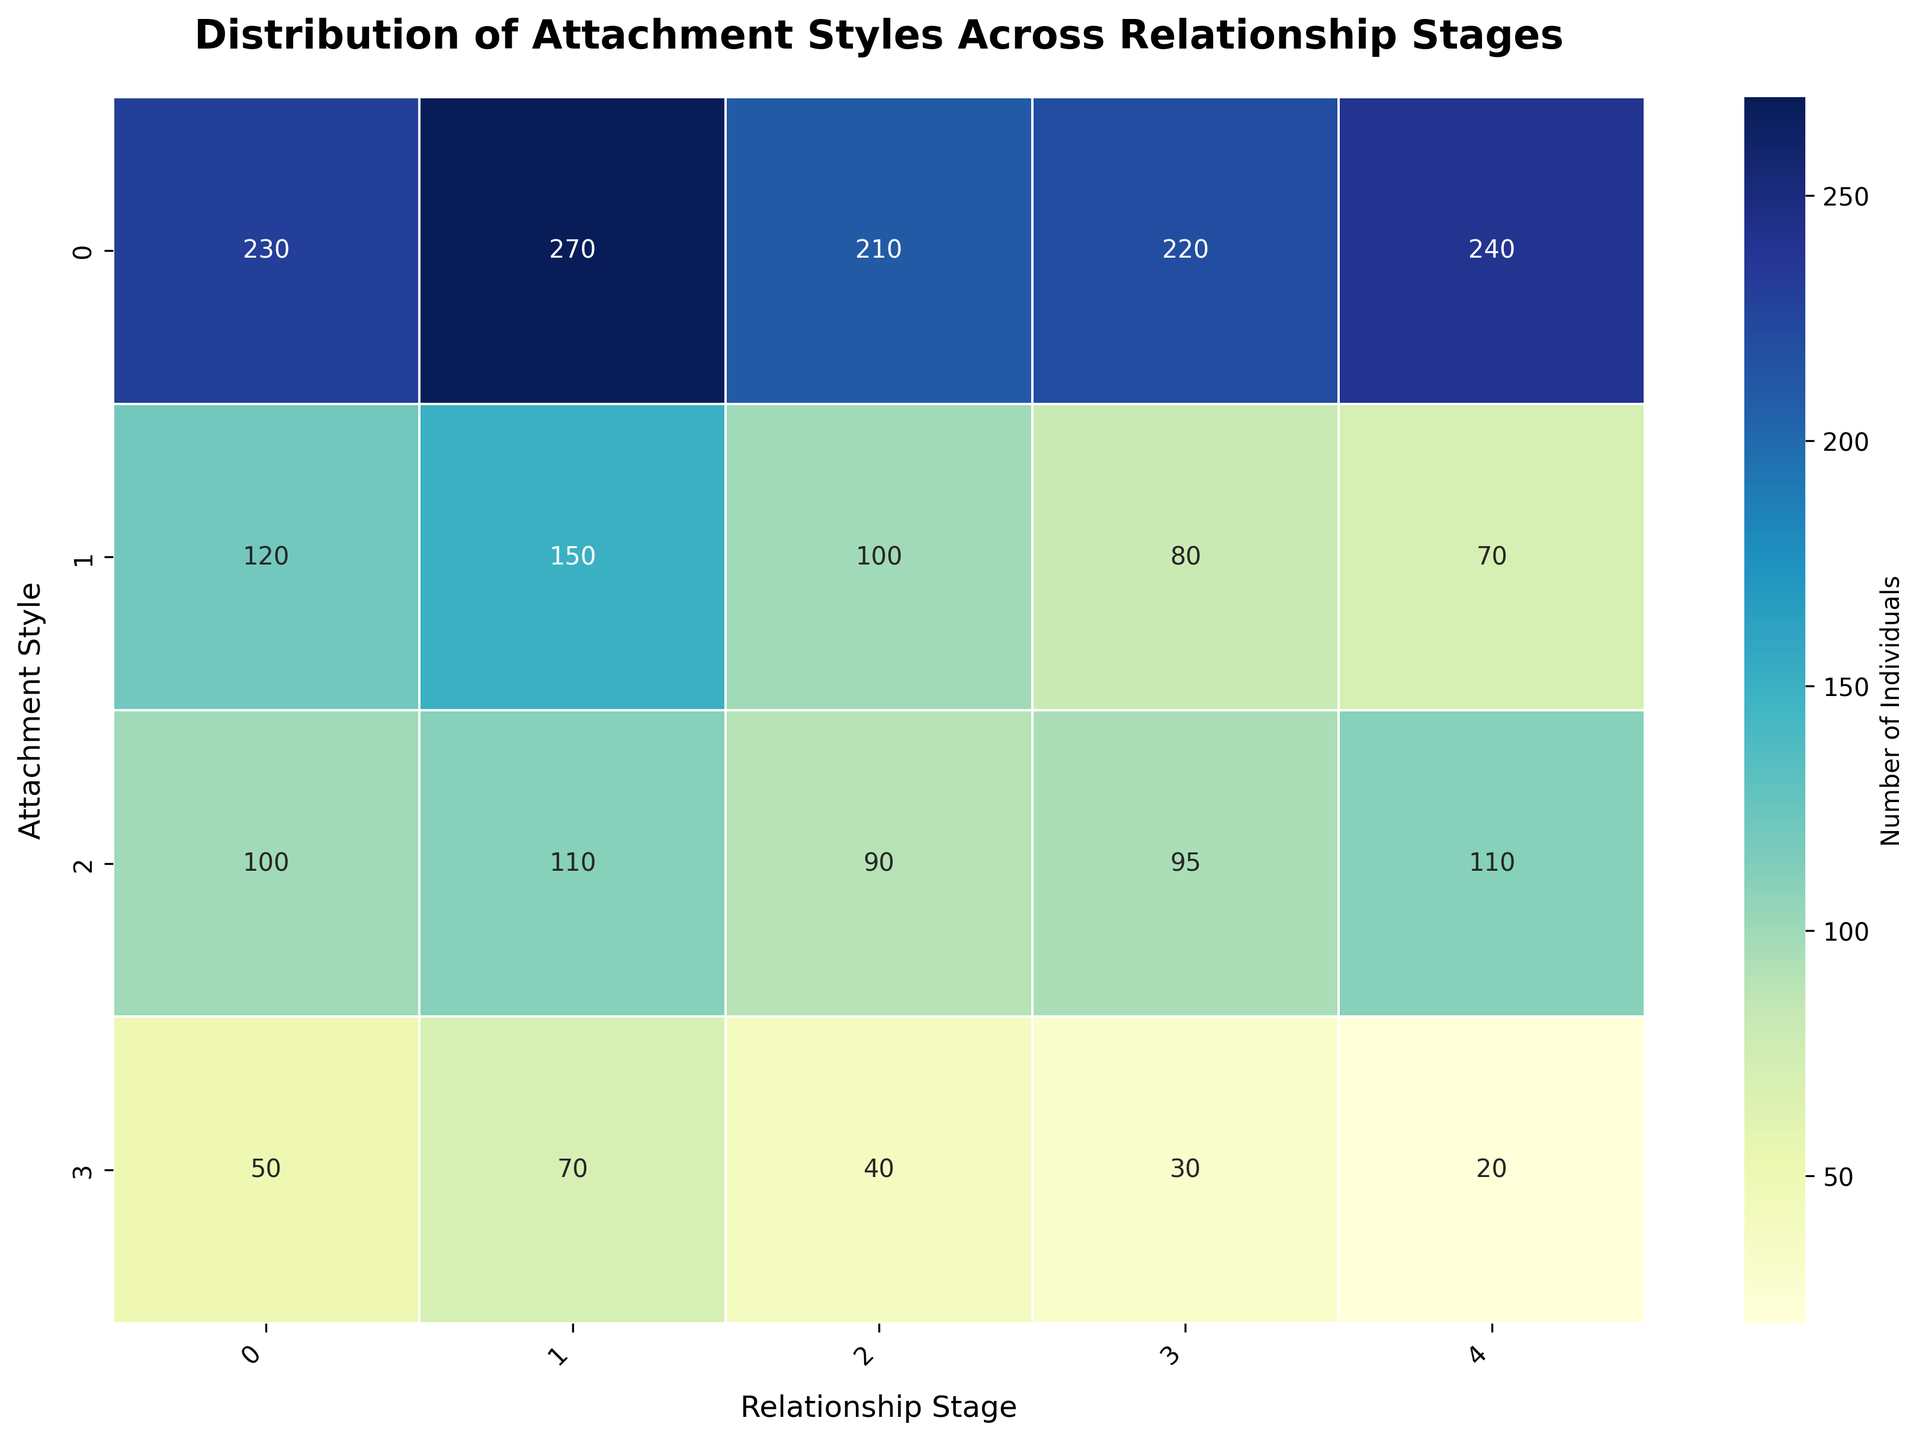What is the title of the heatmap? The title is located at the top of the heatmap and it reads "Distribution of Attachment Styles Across Relationship Stages."
Answer: Distribution of Attachment Styles Across Relationship Stages Which relationship stage has the highest number of securely attached individuals? By examining the values in the "Secure" row, we see that the highest value is 270, which corresponds to the "Dating" column.
Answer: Dating How many individuals are categorized as disorganized across all relationship stages? Sum the values in the "Disorganized" row: 50 (Single) + 70 (Dating) + 40 (Engaged) + 30 (Newlywed) + 20 (Long-term Married) = 210.
Answer: 210 Which attachment style shows an increase in the number of individuals from newlywed to long-term married stages? By comparing the values for the "Newlywed" and "Long-term Married" columns, we see that only the "Avoidant" style increases from 95 to 110.
Answer: Avoidant What is the difference in the number of anxiously attached individuals between the single and newlywed stages? Subtract the number of anxiously attached individuals in the newlywed stage (80) from the single stage (120): 120 - 80 = 40.
Answer: 40 Which attachment style has the lowest representation in the dating stage? By comparing values in the "Dating" column, the lowest value is 70, which corresponds to the "Disorganized" attachment style.
Answer: Disorganized What is the average number of securely attached individuals across all relationship stages? To find the average, sum the values in the "Secure" row and divide by the number of stages: (230 + 270 + 210 + 220 + 240) / 5 = 1170 / 5 = 234.
Answer: 234 Is there any attachment style that shows a consistent decrease in numbers from single to long-term married stages? On examining all rows, we see that the "Anxious" attachment style consistently decreases from 120 (Single) to 70 (Long-term Married).
Answer: Anxious How many more securely attached individuals are there in the newlywed stage compared to the disorganized individuals in the same stage? Subtract the number of disorganized individuals in the newlywed stage (30) from the securely attached individuals in the same stage (220): 220 - 30 = 190.
Answer: 190 Which relationship stage has the most evenly distributed attachment styles? By observing the heatmap, the "Engaged" stage has less variance among attachment style numbers (Secure=210, Anxious=100, Avoidant=90, Disorganized=40).
Answer: Engaged 